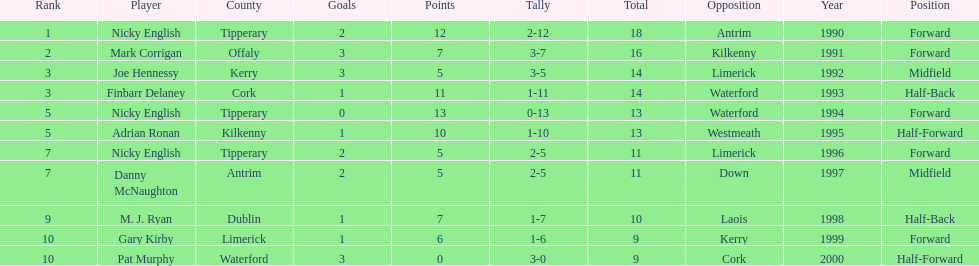What was the average of the totals of nicky english and mark corrigan? 17. 